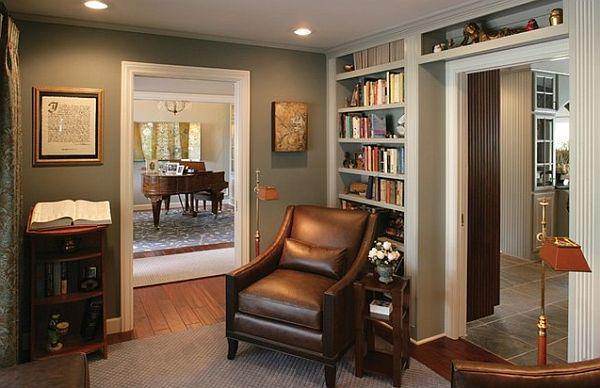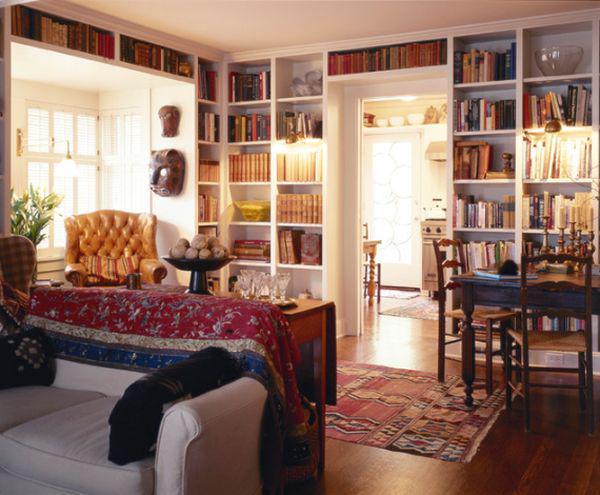The first image is the image on the left, the second image is the image on the right. Evaluate the accuracy of this statement regarding the images: "A dark brown wood table is near a bookcase in one of the images.". Is it true? Answer yes or no. Yes. 